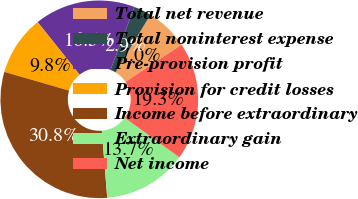Convert chart. <chart><loc_0><loc_0><loc_500><loc_500><pie_chart><fcel>Total net revenue<fcel>Total noninterest expense<fcel>Pre-provision profit<fcel>Provision for credit losses<fcel>Income before extraordinary<fcel>Extraordinary gain<fcel>Net income<nl><fcel>7.01%<fcel>2.86%<fcel>16.52%<fcel>9.8%<fcel>30.76%<fcel>13.73%<fcel>19.31%<nl></chart> 